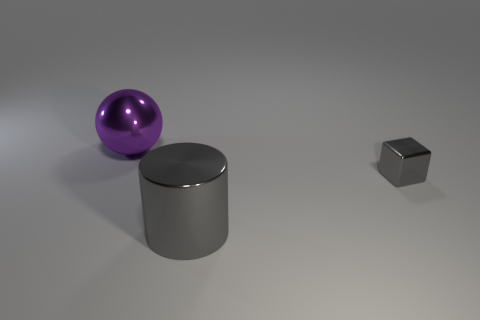Add 2 tiny cyan metal cubes. How many objects exist? 5 Subtract all balls. How many objects are left? 2 Subtract 0 yellow cubes. How many objects are left? 3 Subtract all small brown metal cubes. Subtract all gray cylinders. How many objects are left? 2 Add 2 tiny gray metallic blocks. How many tiny gray metallic blocks are left? 3 Add 3 tiny blocks. How many tiny blocks exist? 4 